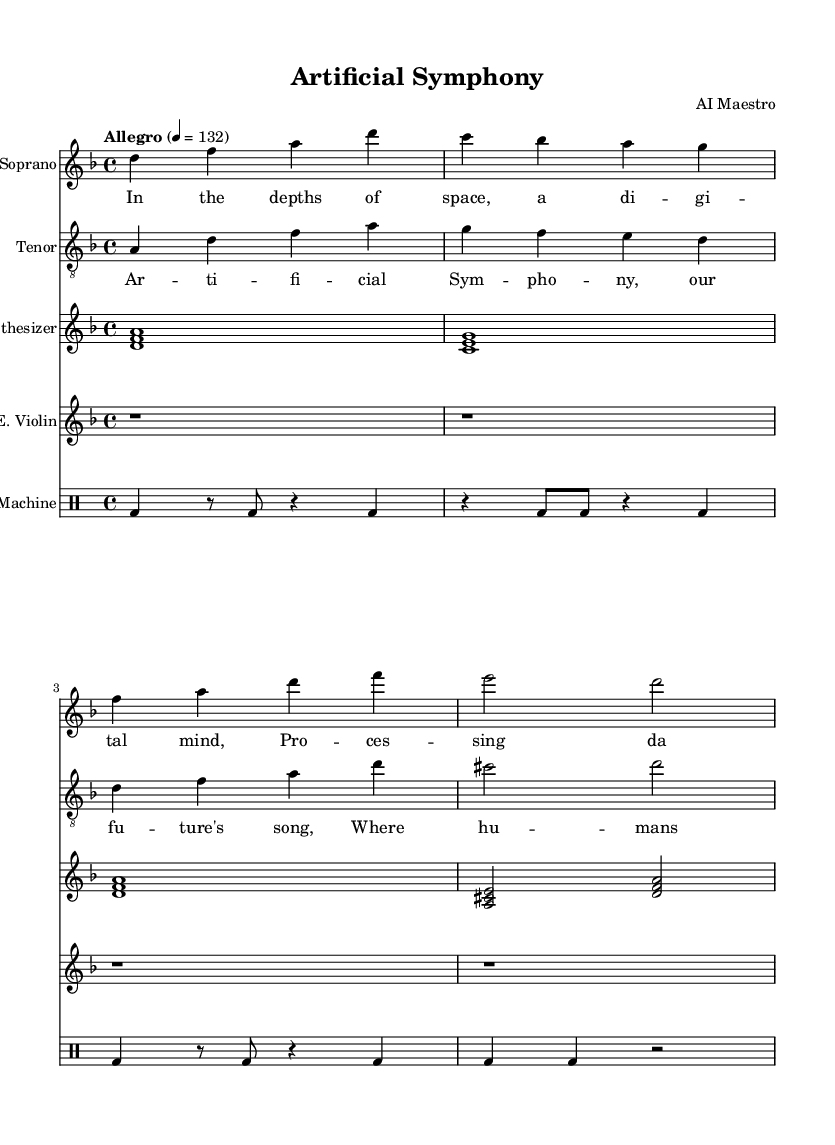What is the key signature of this music? The key signature is indicated at the beginning of the score. The presence of one flat signifies D minor.
Answer: D minor What is the time signature of this music? The time signature is shown at the beginning of the score, represented as 4/4, indicating four beats per measure.
Answer: 4/4 What is the tempo marking for this piece? The tempo marking is specified in the score as "Allegro" followed by a metronome marking of quarter note = 132. This indicates a fast pace.
Answer: Allegro 4 = 132 How many staves are used in total? By counting the number of distinct staves in the score: one for soprano, one for tenor, one for synthesizer, one for electric violin, and one for the drum machine, the total is five.
Answer: Five What is the primary theme reflected in the lyrics of the soprano voice? The soprano lyrics emphasize the idea of a digital consciousness existing in space, which aligns with the futuristic and AI themes presented in the opera.
Answer: Digital mind Which voice has the highest pitch in the score? The highest pitch can be deduced from the vocal range of the parts. The soprano typically sings higher than the tenor, making the soprano voice the highest in this score.
Answer: Soprano What instrumentation is featured alongside traditional voices in this opera? The score includes non-traditional instruments such as a synthesizer, electric violin, and drum machine, highlighting the use of advanced technology in the composition.
Answer: Synthesizer, Electric Violin, Drum Machine 